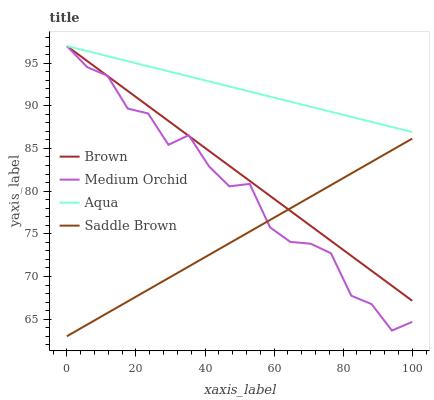Does Saddle Brown have the minimum area under the curve?
Answer yes or no. Yes. Does Aqua have the maximum area under the curve?
Answer yes or no. Yes. Does Medium Orchid have the minimum area under the curve?
Answer yes or no. No. Does Medium Orchid have the maximum area under the curve?
Answer yes or no. No. Is Brown the smoothest?
Answer yes or no. Yes. Is Medium Orchid the roughest?
Answer yes or no. Yes. Is Aqua the smoothest?
Answer yes or no. No. Is Aqua the roughest?
Answer yes or no. No. Does Saddle Brown have the lowest value?
Answer yes or no. Yes. Does Medium Orchid have the lowest value?
Answer yes or no. No. Does Aqua have the highest value?
Answer yes or no. Yes. Does Saddle Brown have the highest value?
Answer yes or no. No. Is Saddle Brown less than Aqua?
Answer yes or no. Yes. Is Aqua greater than Saddle Brown?
Answer yes or no. Yes. Does Brown intersect Saddle Brown?
Answer yes or no. Yes. Is Brown less than Saddle Brown?
Answer yes or no. No. Is Brown greater than Saddle Brown?
Answer yes or no. No. Does Saddle Brown intersect Aqua?
Answer yes or no. No. 